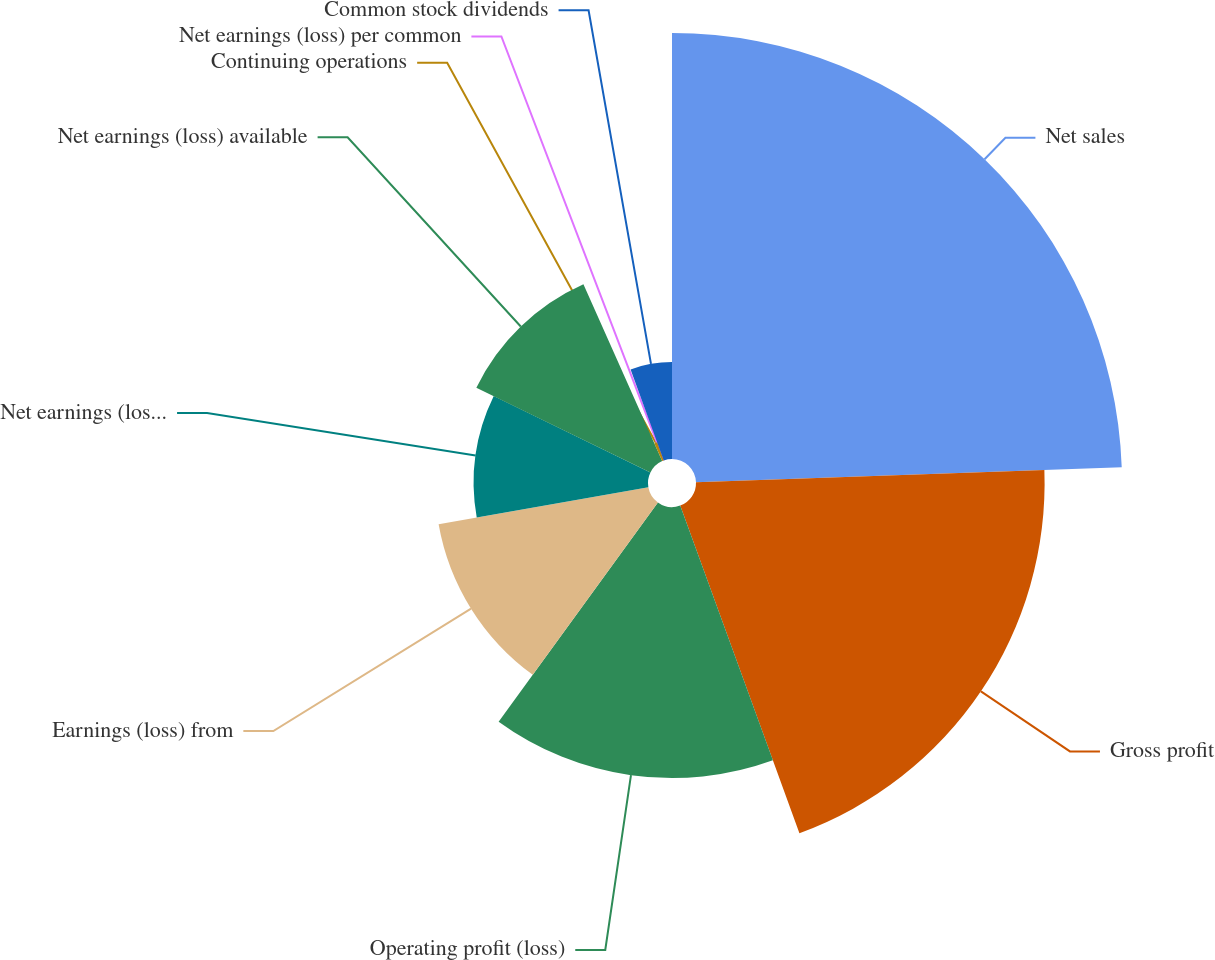<chart> <loc_0><loc_0><loc_500><loc_500><pie_chart><fcel>Net sales<fcel>Gross profit<fcel>Operating profit (loss)<fcel>Earnings (loss) from<fcel>Net earnings (loss) from<fcel>Net earnings (loss) available<fcel>Continuing operations<fcel>Net earnings (loss) per common<fcel>Common stock dividends<nl><fcel>24.44%<fcel>20.0%<fcel>15.55%<fcel>12.22%<fcel>10.0%<fcel>11.11%<fcel>1.11%<fcel>0.0%<fcel>5.56%<nl></chart> 